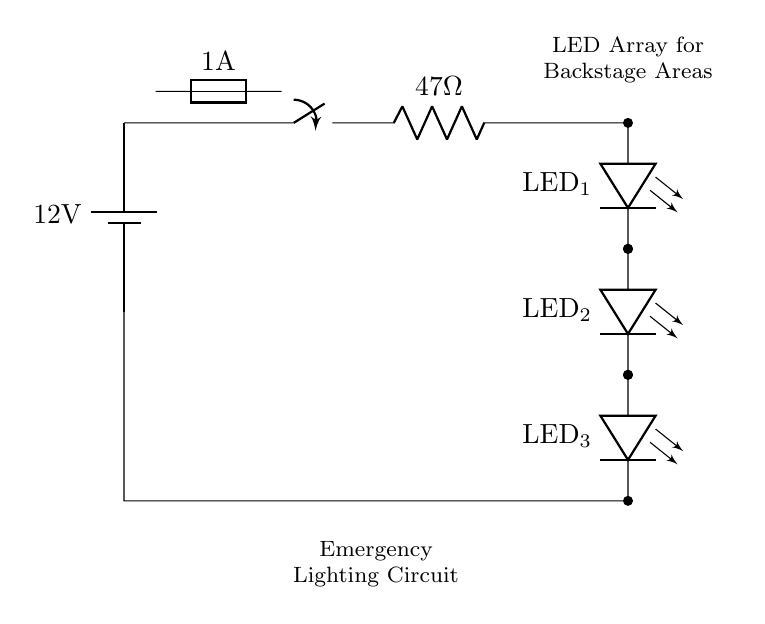What is the voltage of the battery? The battery in the circuit is labeled with a voltage of 12 volts, which indicates the potential difference it supplies.
Answer: 12 volts What type of switch is used in this circuit? The circuit diagram indicates a switch, specifically a generic switch symbol, which can be manually operated, allowing or interrupting the current flow.
Answer: Switch How many LEDs are in the array? The circuit diagram shows three LED components connected in series, each labeled clearly as LED one, LED two, and LED three.
Answer: Three What is the value of the current limiting resistor? The circuit diagram specifies the resistor value next to the resistor symbol, which is 47 ohms, used to limit the current flowing through the LEDs.
Answer: 47 ohms What is the purpose of the fuse in this circuit? The fuse, indicated on the circuit, is designed to protect the circuit by breaking the connection if the current exceeds 1 ampere, thus preventing potential damage from overcurrent.
Answer: Protection If the LEDs are turned on, what current would flow through them? To find the current flowing through the LEDs, we can use Ohm's Law (current = voltage / resistance). With a 12-volt battery and a 47-ohm resistor, the current can be calculated as 12 volts divided by 47 ohms, which approximately equals 0.255 amps.
Answer: Approximately 0.255 amps What is the main application of this circuit? This circuit is primarily used for emergency lighting in backstage areas, as indicated by the labeling, showing that it is intended to provide light during power outages or emergencies.
Answer: Emergency lighting 